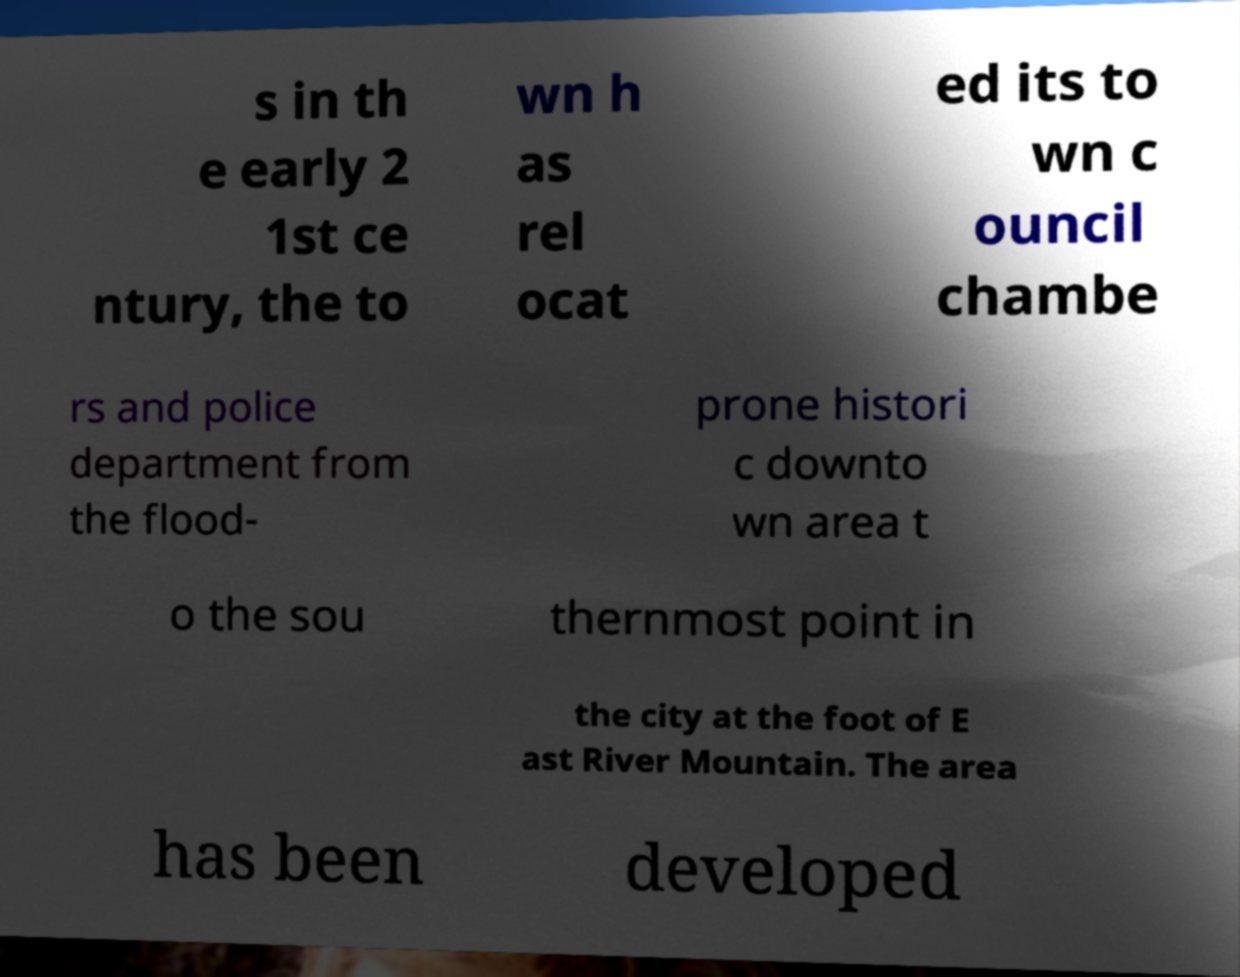I need the written content from this picture converted into text. Can you do that? s in th e early 2 1st ce ntury, the to wn h as rel ocat ed its to wn c ouncil chambe rs and police department from the flood- prone histori c downto wn area t o the sou thernmost point in the city at the foot of E ast River Mountain. The area has been developed 